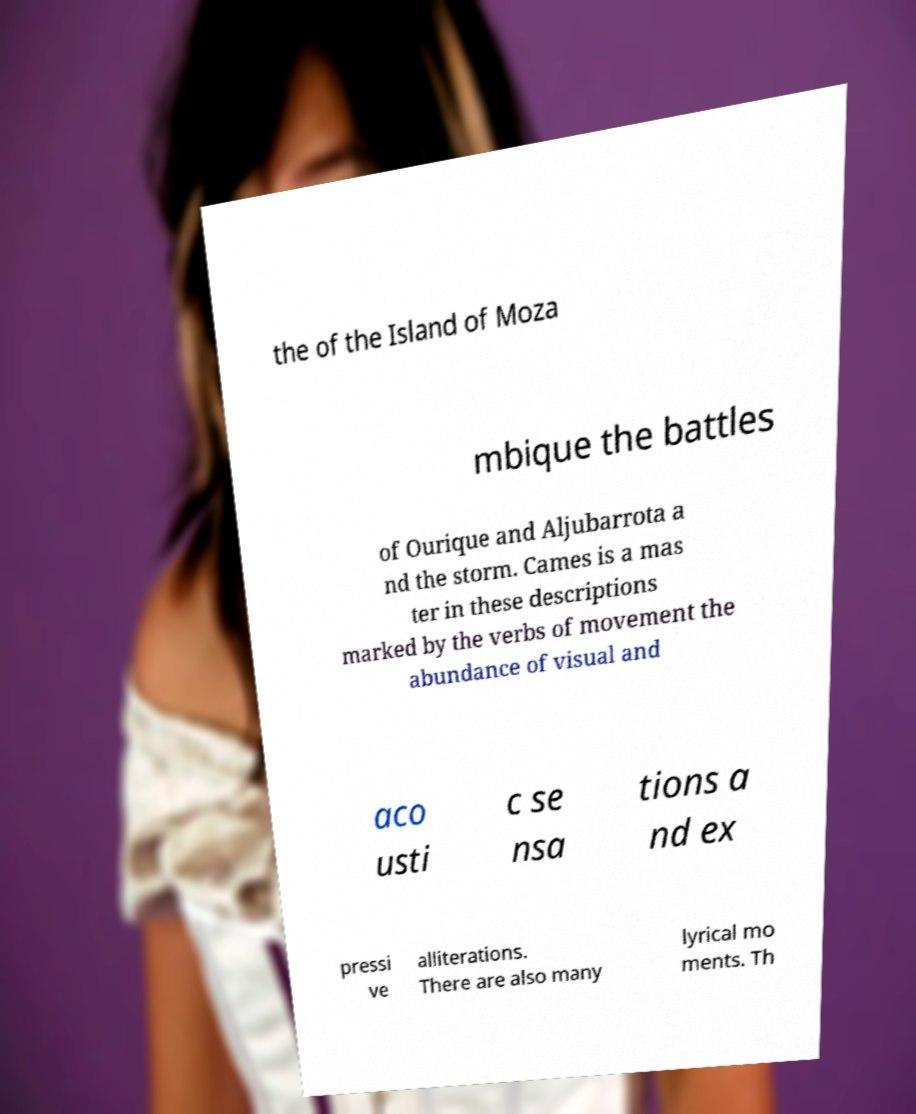There's text embedded in this image that I need extracted. Can you transcribe it verbatim? the of the Island of Moza mbique the battles of Ourique and Aljubarrota a nd the storm. Cames is a mas ter in these descriptions marked by the verbs of movement the abundance of visual and aco usti c se nsa tions a nd ex pressi ve alliterations. There are also many lyrical mo ments. Th 